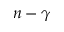<formula> <loc_0><loc_0><loc_500><loc_500>n - \gamma</formula> 